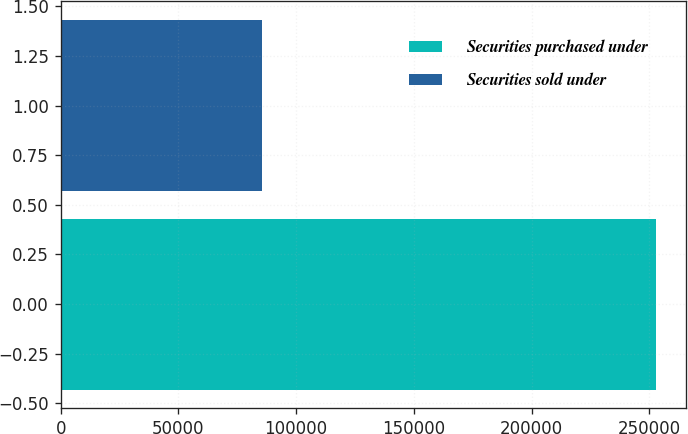Convert chart. <chart><loc_0><loc_0><loc_500><loc_500><bar_chart><fcel>Securities purchased under<fcel>Securities sold under<nl><fcel>252971<fcel>85421<nl></chart> 